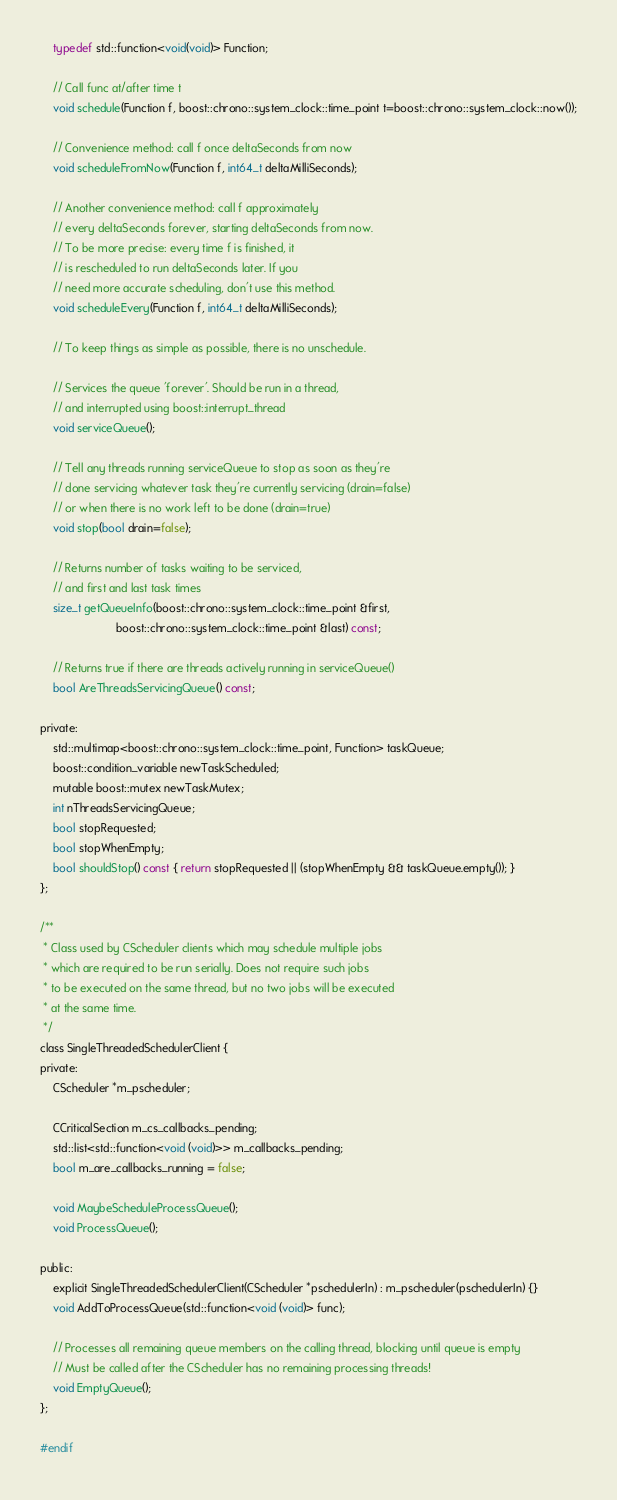Convert code to text. <code><loc_0><loc_0><loc_500><loc_500><_C_>    typedef std::function<void(void)> Function;

    // Call func at/after time t
    void schedule(Function f, boost::chrono::system_clock::time_point t=boost::chrono::system_clock::now());

    // Convenience method: call f once deltaSeconds from now
    void scheduleFromNow(Function f, int64_t deltaMilliSeconds);

    // Another convenience method: call f approximately
    // every deltaSeconds forever, starting deltaSeconds from now.
    // To be more precise: every time f is finished, it
    // is rescheduled to run deltaSeconds later. If you
    // need more accurate scheduling, don't use this method.
    void scheduleEvery(Function f, int64_t deltaMilliSeconds);

    // To keep things as simple as possible, there is no unschedule.

    // Services the queue 'forever'. Should be run in a thread,
    // and interrupted using boost::interrupt_thread
    void serviceQueue();

    // Tell any threads running serviceQueue to stop as soon as they're
    // done servicing whatever task they're currently servicing (drain=false)
    // or when there is no work left to be done (drain=true)
    void stop(bool drain=false);

    // Returns number of tasks waiting to be serviced,
    // and first and last task times
    size_t getQueueInfo(boost::chrono::system_clock::time_point &first,
                        boost::chrono::system_clock::time_point &last) const;

    // Returns true if there are threads actively running in serviceQueue()
    bool AreThreadsServicingQueue() const;

private:
    std::multimap<boost::chrono::system_clock::time_point, Function> taskQueue;
    boost::condition_variable newTaskScheduled;
    mutable boost::mutex newTaskMutex;
    int nThreadsServicingQueue;
    bool stopRequested;
    bool stopWhenEmpty;
    bool shouldStop() const { return stopRequested || (stopWhenEmpty && taskQueue.empty()); }
};

/**
 * Class used by CScheduler clients which may schedule multiple jobs
 * which are required to be run serially. Does not require such jobs
 * to be executed on the same thread, but no two jobs will be executed
 * at the same time.
 */
class SingleThreadedSchedulerClient {
private:
    CScheduler *m_pscheduler;

    CCriticalSection m_cs_callbacks_pending;
    std::list<std::function<void (void)>> m_callbacks_pending;
    bool m_are_callbacks_running = false;

    void MaybeScheduleProcessQueue();
    void ProcessQueue();

public:
    explicit SingleThreadedSchedulerClient(CScheduler *pschedulerIn) : m_pscheduler(pschedulerIn) {}
    void AddToProcessQueue(std::function<void (void)> func);

    // Processes all remaining queue members on the calling thread, blocking until queue is empty
    // Must be called after the CScheduler has no remaining processing threads!
    void EmptyQueue();
};

#endif
</code> 